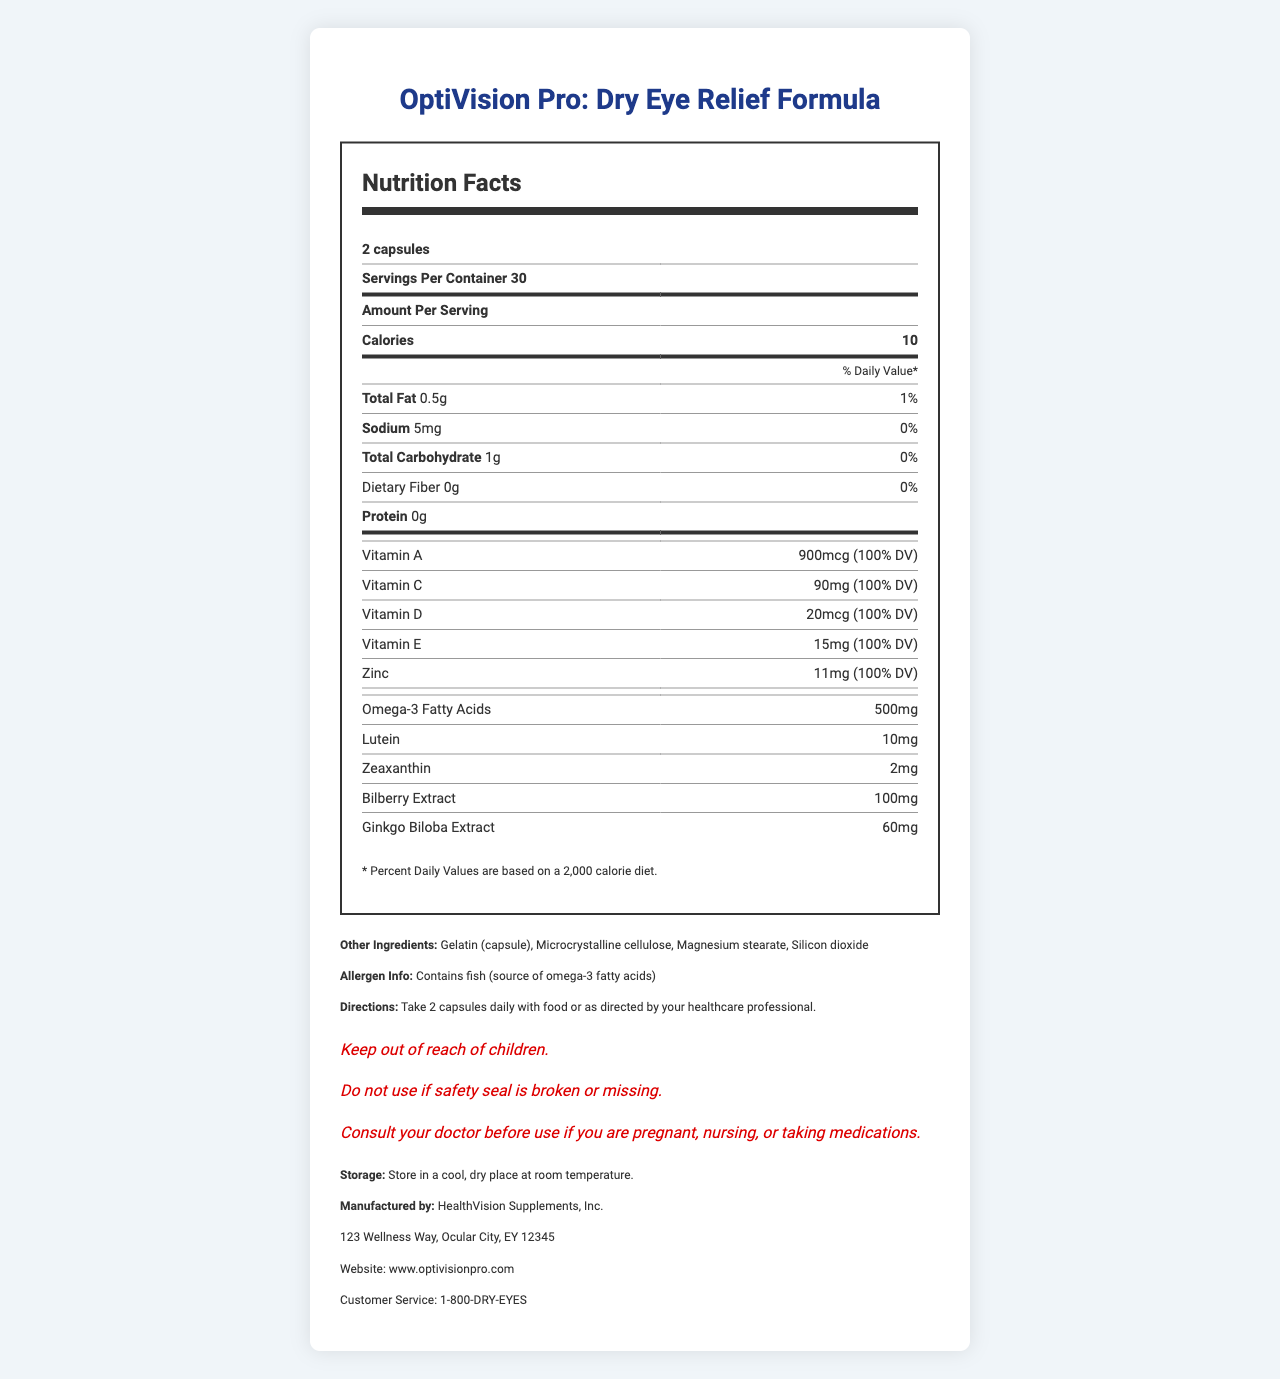what is the name of the product? The product name is displayed prominently at the top of the document.
Answer: OptiVision Pro: Dry Eye Relief Formula what is the serving size? The serving size is mentioned in the section labeled “Nutrition Facts” at the beginning.
Answer: 2 capsules how many servings are in a container? The number of servings per container is indicated under the serving size.
Answer: 30 what is the total amount of calories in one serving? The document states "Calories 10" under the “Amount Per Serving” section.
Answer: 10 calories how much vitamin A is in each serving? Vitamin A content per serving is listed in the nutrition facts with its Daily Value percentage.
Answer: 900mcg (100% DV) does the product contain any fish allergens? The allergen information states that the product contains fish, which is the source of omega-3 fatty acids.
Answer: Yes which of the following vitamins are included in the OptiVision Pro: Dry Eye Relief Formula? A. Vitamin B B. Vitamin A C. Vitamin K D. Vitamin E Both Vitamin A and Vitamin E are mentioned in the nutrition facts.
Answer: B and D what is the percentage daily value of Vitamin C in one serving? A. 90% B. 100% C. 110% D. 50% The document specifies that the daily value for Vitamin C is 100% in one serving.
Answer: B. 100% is it safe for pregnant women to use this product without consulting a doctor? Yes/No The warnings state to consult a doctor before use if you are pregnant, nursing, or taking medications.
Answer: No summarize the main idea of this document. This summary captures the core sections and types of information presented in the document, which relate to nutrient content, potential allergens, and usage guidelines.
Answer: The document provides detailed information about the OptiVision Pro: Dry Eye Relief Formula, including its nutrition facts, ingredient information, allergen warnings, usage directions, storage instructions, and manufacturer details. what is the role of bilberry extract in the product? The document only lists the ingredient and its quantity; it does not describe the role or benefits of bilberry extract.
Answer: Not enough information 